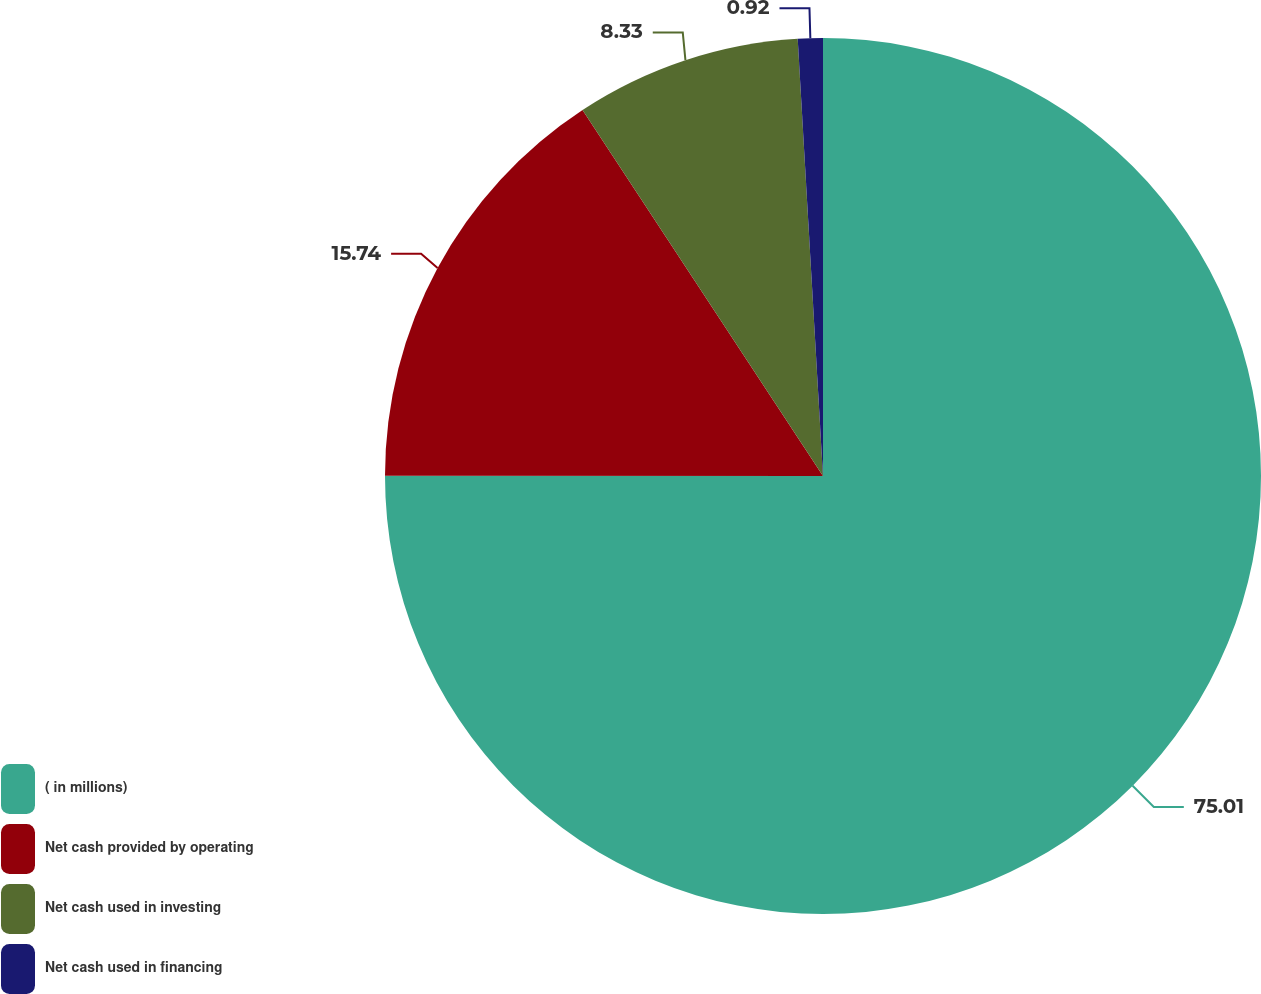Convert chart. <chart><loc_0><loc_0><loc_500><loc_500><pie_chart><fcel>( in millions)<fcel>Net cash provided by operating<fcel>Net cash used in investing<fcel>Net cash used in financing<nl><fcel>75.01%<fcel>15.74%<fcel>8.33%<fcel>0.92%<nl></chart> 